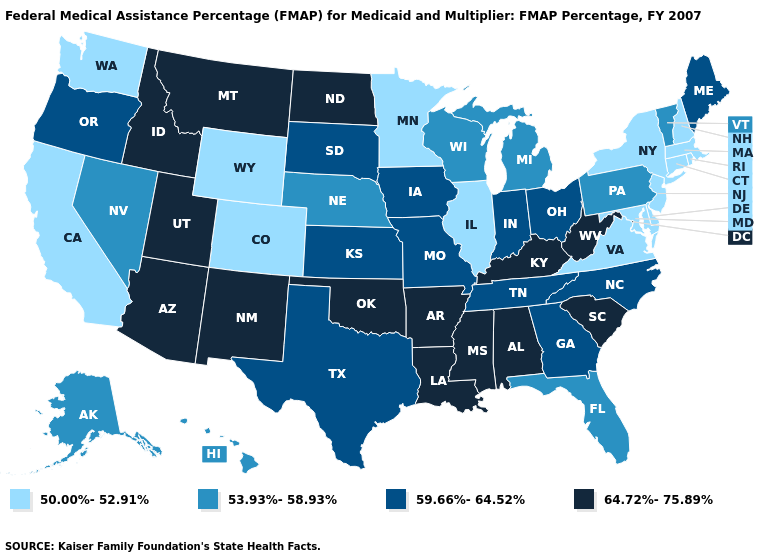What is the value of Georgia?
Write a very short answer. 59.66%-64.52%. Name the states that have a value in the range 59.66%-64.52%?
Quick response, please. Georgia, Indiana, Iowa, Kansas, Maine, Missouri, North Carolina, Ohio, Oregon, South Dakota, Tennessee, Texas. Among the states that border Idaho , which have the lowest value?
Be succinct. Washington, Wyoming. What is the lowest value in the USA?
Give a very brief answer. 50.00%-52.91%. Name the states that have a value in the range 50.00%-52.91%?
Keep it brief. California, Colorado, Connecticut, Delaware, Illinois, Maryland, Massachusetts, Minnesota, New Hampshire, New Jersey, New York, Rhode Island, Virginia, Washington, Wyoming. What is the value of Montana?
Answer briefly. 64.72%-75.89%. What is the lowest value in states that border Colorado?
Concise answer only. 50.00%-52.91%. Does the first symbol in the legend represent the smallest category?
Short answer required. Yes. What is the value of Georgia?
Short answer required. 59.66%-64.52%. Does the first symbol in the legend represent the smallest category?
Be succinct. Yes. Does Wisconsin have a lower value than New Jersey?
Keep it brief. No. Does Vermont have the same value as California?
Quick response, please. No. Name the states that have a value in the range 50.00%-52.91%?
Answer briefly. California, Colorado, Connecticut, Delaware, Illinois, Maryland, Massachusetts, Minnesota, New Hampshire, New Jersey, New York, Rhode Island, Virginia, Washington, Wyoming. Does the first symbol in the legend represent the smallest category?
Be succinct. Yes. 